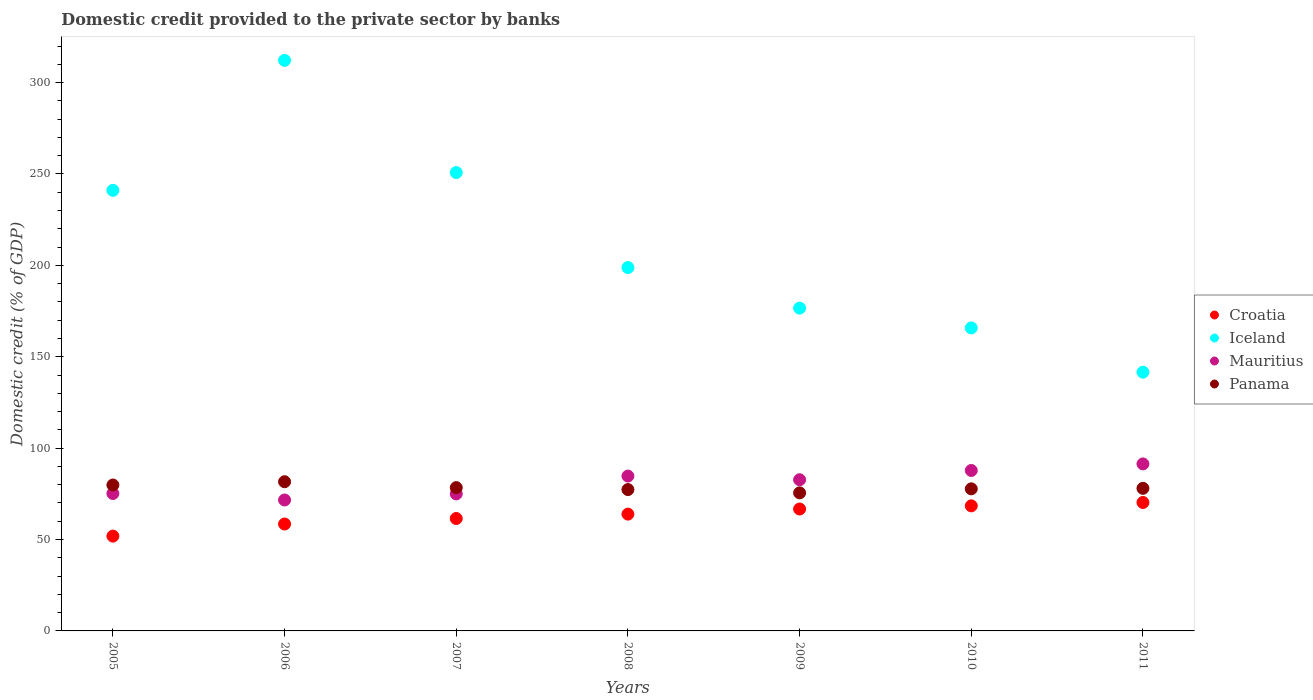How many different coloured dotlines are there?
Make the answer very short. 4. Is the number of dotlines equal to the number of legend labels?
Offer a terse response. Yes. What is the domestic credit provided to the private sector by banks in Mauritius in 2008?
Ensure brevity in your answer.  84.72. Across all years, what is the maximum domestic credit provided to the private sector by banks in Panama?
Give a very brief answer. 81.63. Across all years, what is the minimum domestic credit provided to the private sector by banks in Panama?
Provide a succinct answer. 75.54. In which year was the domestic credit provided to the private sector by banks in Mauritius maximum?
Provide a succinct answer. 2011. In which year was the domestic credit provided to the private sector by banks in Panama minimum?
Your answer should be very brief. 2009. What is the total domestic credit provided to the private sector by banks in Iceland in the graph?
Your response must be concise. 1486.71. What is the difference between the domestic credit provided to the private sector by banks in Panama in 2006 and that in 2010?
Offer a terse response. 3.89. What is the difference between the domestic credit provided to the private sector by banks in Mauritius in 2006 and the domestic credit provided to the private sector by banks in Panama in 2007?
Provide a short and direct response. -6.77. What is the average domestic credit provided to the private sector by banks in Panama per year?
Provide a short and direct response. 78.35. In the year 2011, what is the difference between the domestic credit provided to the private sector by banks in Mauritius and domestic credit provided to the private sector by banks in Croatia?
Make the answer very short. 21.1. In how many years, is the domestic credit provided to the private sector by banks in Croatia greater than 160 %?
Keep it short and to the point. 0. What is the ratio of the domestic credit provided to the private sector by banks in Mauritius in 2007 to that in 2009?
Keep it short and to the point. 0.91. Is the difference between the domestic credit provided to the private sector by banks in Mauritius in 2008 and 2011 greater than the difference between the domestic credit provided to the private sector by banks in Croatia in 2008 and 2011?
Offer a very short reply. No. What is the difference between the highest and the second highest domestic credit provided to the private sector by banks in Croatia?
Your response must be concise. 1.84. What is the difference between the highest and the lowest domestic credit provided to the private sector by banks in Iceland?
Provide a succinct answer. 170.59. In how many years, is the domestic credit provided to the private sector by banks in Panama greater than the average domestic credit provided to the private sector by banks in Panama taken over all years?
Provide a succinct answer. 3. Is it the case that in every year, the sum of the domestic credit provided to the private sector by banks in Panama and domestic credit provided to the private sector by banks in Mauritius  is greater than the sum of domestic credit provided to the private sector by banks in Iceland and domestic credit provided to the private sector by banks in Croatia?
Your answer should be very brief. Yes. Does the domestic credit provided to the private sector by banks in Croatia monotonically increase over the years?
Provide a succinct answer. Yes. Is the domestic credit provided to the private sector by banks in Mauritius strictly greater than the domestic credit provided to the private sector by banks in Panama over the years?
Provide a short and direct response. No. How many dotlines are there?
Offer a very short reply. 4. Are the values on the major ticks of Y-axis written in scientific E-notation?
Give a very brief answer. No. Does the graph contain any zero values?
Your answer should be very brief. No. Where does the legend appear in the graph?
Make the answer very short. Center right. What is the title of the graph?
Provide a short and direct response. Domestic credit provided to the private sector by banks. Does "Guinea" appear as one of the legend labels in the graph?
Keep it short and to the point. No. What is the label or title of the X-axis?
Your response must be concise. Years. What is the label or title of the Y-axis?
Provide a succinct answer. Domestic credit (% of GDP). What is the Domestic credit (% of GDP) in Croatia in 2005?
Give a very brief answer. 51.87. What is the Domestic credit (% of GDP) of Iceland in 2005?
Offer a terse response. 241.04. What is the Domestic credit (% of GDP) of Mauritius in 2005?
Ensure brevity in your answer.  75.18. What is the Domestic credit (% of GDP) in Panama in 2005?
Ensure brevity in your answer.  79.83. What is the Domestic credit (% of GDP) of Croatia in 2006?
Provide a short and direct response. 58.49. What is the Domestic credit (% of GDP) in Iceland in 2006?
Give a very brief answer. 312.15. What is the Domestic credit (% of GDP) of Mauritius in 2006?
Your answer should be compact. 71.63. What is the Domestic credit (% of GDP) of Panama in 2006?
Offer a terse response. 81.63. What is the Domestic credit (% of GDP) of Croatia in 2007?
Give a very brief answer. 61.5. What is the Domestic credit (% of GDP) in Iceland in 2007?
Provide a short and direct response. 250.76. What is the Domestic credit (% of GDP) in Mauritius in 2007?
Ensure brevity in your answer.  74.97. What is the Domestic credit (% of GDP) in Panama in 2007?
Ensure brevity in your answer.  78.4. What is the Domestic credit (% of GDP) of Croatia in 2008?
Your answer should be compact. 63.9. What is the Domestic credit (% of GDP) of Iceland in 2008?
Provide a short and direct response. 198.81. What is the Domestic credit (% of GDP) of Mauritius in 2008?
Your answer should be compact. 84.72. What is the Domestic credit (% of GDP) of Panama in 2008?
Offer a terse response. 77.33. What is the Domestic credit (% of GDP) in Croatia in 2009?
Make the answer very short. 66.7. What is the Domestic credit (% of GDP) in Iceland in 2009?
Provide a succinct answer. 176.6. What is the Domestic credit (% of GDP) of Mauritius in 2009?
Make the answer very short. 82.71. What is the Domestic credit (% of GDP) of Panama in 2009?
Provide a succinct answer. 75.54. What is the Domestic credit (% of GDP) in Croatia in 2010?
Provide a succinct answer. 68.43. What is the Domestic credit (% of GDP) of Iceland in 2010?
Keep it short and to the point. 165.78. What is the Domestic credit (% of GDP) of Mauritius in 2010?
Your response must be concise. 87.78. What is the Domestic credit (% of GDP) of Panama in 2010?
Your answer should be compact. 77.74. What is the Domestic credit (% of GDP) of Croatia in 2011?
Your answer should be compact. 70.27. What is the Domestic credit (% of GDP) in Iceland in 2011?
Provide a succinct answer. 141.56. What is the Domestic credit (% of GDP) in Mauritius in 2011?
Give a very brief answer. 91.37. What is the Domestic credit (% of GDP) in Panama in 2011?
Provide a short and direct response. 78.01. Across all years, what is the maximum Domestic credit (% of GDP) in Croatia?
Offer a terse response. 70.27. Across all years, what is the maximum Domestic credit (% of GDP) in Iceland?
Ensure brevity in your answer.  312.15. Across all years, what is the maximum Domestic credit (% of GDP) in Mauritius?
Provide a short and direct response. 91.37. Across all years, what is the maximum Domestic credit (% of GDP) in Panama?
Your answer should be very brief. 81.63. Across all years, what is the minimum Domestic credit (% of GDP) of Croatia?
Give a very brief answer. 51.87. Across all years, what is the minimum Domestic credit (% of GDP) in Iceland?
Provide a succinct answer. 141.56. Across all years, what is the minimum Domestic credit (% of GDP) in Mauritius?
Give a very brief answer. 71.63. Across all years, what is the minimum Domestic credit (% of GDP) in Panama?
Offer a terse response. 75.54. What is the total Domestic credit (% of GDP) of Croatia in the graph?
Provide a succinct answer. 441.15. What is the total Domestic credit (% of GDP) of Iceland in the graph?
Your response must be concise. 1486.71. What is the total Domestic credit (% of GDP) in Mauritius in the graph?
Provide a short and direct response. 568.36. What is the total Domestic credit (% of GDP) in Panama in the graph?
Provide a succinct answer. 548.47. What is the difference between the Domestic credit (% of GDP) in Croatia in 2005 and that in 2006?
Your response must be concise. -6.62. What is the difference between the Domestic credit (% of GDP) of Iceland in 2005 and that in 2006?
Offer a terse response. -71.11. What is the difference between the Domestic credit (% of GDP) of Mauritius in 2005 and that in 2006?
Your response must be concise. 3.55. What is the difference between the Domestic credit (% of GDP) in Panama in 2005 and that in 2006?
Keep it short and to the point. -1.8. What is the difference between the Domestic credit (% of GDP) in Croatia in 2005 and that in 2007?
Keep it short and to the point. -9.63. What is the difference between the Domestic credit (% of GDP) in Iceland in 2005 and that in 2007?
Offer a very short reply. -9.72. What is the difference between the Domestic credit (% of GDP) of Mauritius in 2005 and that in 2007?
Ensure brevity in your answer.  0.21. What is the difference between the Domestic credit (% of GDP) in Panama in 2005 and that in 2007?
Give a very brief answer. 1.43. What is the difference between the Domestic credit (% of GDP) of Croatia in 2005 and that in 2008?
Provide a succinct answer. -12.03. What is the difference between the Domestic credit (% of GDP) of Iceland in 2005 and that in 2008?
Your response must be concise. 42.24. What is the difference between the Domestic credit (% of GDP) in Mauritius in 2005 and that in 2008?
Your response must be concise. -9.55. What is the difference between the Domestic credit (% of GDP) in Panama in 2005 and that in 2008?
Keep it short and to the point. 2.5. What is the difference between the Domestic credit (% of GDP) of Croatia in 2005 and that in 2009?
Give a very brief answer. -14.83. What is the difference between the Domestic credit (% of GDP) in Iceland in 2005 and that in 2009?
Offer a terse response. 64.44. What is the difference between the Domestic credit (% of GDP) in Mauritius in 2005 and that in 2009?
Give a very brief answer. -7.53. What is the difference between the Domestic credit (% of GDP) of Panama in 2005 and that in 2009?
Make the answer very short. 4.29. What is the difference between the Domestic credit (% of GDP) in Croatia in 2005 and that in 2010?
Keep it short and to the point. -16.56. What is the difference between the Domestic credit (% of GDP) in Iceland in 2005 and that in 2010?
Your response must be concise. 75.26. What is the difference between the Domestic credit (% of GDP) in Mauritius in 2005 and that in 2010?
Ensure brevity in your answer.  -12.6. What is the difference between the Domestic credit (% of GDP) in Panama in 2005 and that in 2010?
Provide a succinct answer. 2.1. What is the difference between the Domestic credit (% of GDP) of Croatia in 2005 and that in 2011?
Give a very brief answer. -18.4. What is the difference between the Domestic credit (% of GDP) of Iceland in 2005 and that in 2011?
Offer a terse response. 99.48. What is the difference between the Domestic credit (% of GDP) of Mauritius in 2005 and that in 2011?
Provide a succinct answer. -16.19. What is the difference between the Domestic credit (% of GDP) of Panama in 2005 and that in 2011?
Ensure brevity in your answer.  1.82. What is the difference between the Domestic credit (% of GDP) of Croatia in 2006 and that in 2007?
Offer a terse response. -3.01. What is the difference between the Domestic credit (% of GDP) in Iceland in 2006 and that in 2007?
Your answer should be compact. 61.39. What is the difference between the Domestic credit (% of GDP) of Mauritius in 2006 and that in 2007?
Your response must be concise. -3.34. What is the difference between the Domestic credit (% of GDP) in Panama in 2006 and that in 2007?
Your response must be concise. 3.23. What is the difference between the Domestic credit (% of GDP) of Croatia in 2006 and that in 2008?
Your answer should be very brief. -5.41. What is the difference between the Domestic credit (% of GDP) of Iceland in 2006 and that in 2008?
Give a very brief answer. 113.35. What is the difference between the Domestic credit (% of GDP) in Mauritius in 2006 and that in 2008?
Make the answer very short. -13.09. What is the difference between the Domestic credit (% of GDP) in Panama in 2006 and that in 2008?
Offer a terse response. 4.3. What is the difference between the Domestic credit (% of GDP) in Croatia in 2006 and that in 2009?
Your answer should be compact. -8.22. What is the difference between the Domestic credit (% of GDP) in Iceland in 2006 and that in 2009?
Provide a succinct answer. 135.55. What is the difference between the Domestic credit (% of GDP) of Mauritius in 2006 and that in 2009?
Make the answer very short. -11.08. What is the difference between the Domestic credit (% of GDP) in Panama in 2006 and that in 2009?
Offer a very short reply. 6.09. What is the difference between the Domestic credit (% of GDP) of Croatia in 2006 and that in 2010?
Keep it short and to the point. -9.94. What is the difference between the Domestic credit (% of GDP) of Iceland in 2006 and that in 2010?
Give a very brief answer. 146.37. What is the difference between the Domestic credit (% of GDP) of Mauritius in 2006 and that in 2010?
Your answer should be compact. -16.15. What is the difference between the Domestic credit (% of GDP) in Panama in 2006 and that in 2010?
Offer a very short reply. 3.89. What is the difference between the Domestic credit (% of GDP) in Croatia in 2006 and that in 2011?
Your answer should be very brief. -11.78. What is the difference between the Domestic credit (% of GDP) in Iceland in 2006 and that in 2011?
Provide a succinct answer. 170.59. What is the difference between the Domestic credit (% of GDP) in Mauritius in 2006 and that in 2011?
Ensure brevity in your answer.  -19.74. What is the difference between the Domestic credit (% of GDP) of Panama in 2006 and that in 2011?
Ensure brevity in your answer.  3.62. What is the difference between the Domestic credit (% of GDP) of Croatia in 2007 and that in 2008?
Offer a very short reply. -2.4. What is the difference between the Domestic credit (% of GDP) of Iceland in 2007 and that in 2008?
Ensure brevity in your answer.  51.96. What is the difference between the Domestic credit (% of GDP) of Mauritius in 2007 and that in 2008?
Your answer should be very brief. -9.76. What is the difference between the Domestic credit (% of GDP) of Panama in 2007 and that in 2008?
Offer a terse response. 1.07. What is the difference between the Domestic credit (% of GDP) of Croatia in 2007 and that in 2009?
Give a very brief answer. -5.2. What is the difference between the Domestic credit (% of GDP) of Iceland in 2007 and that in 2009?
Make the answer very short. 74.16. What is the difference between the Domestic credit (% of GDP) of Mauritius in 2007 and that in 2009?
Offer a terse response. -7.74. What is the difference between the Domestic credit (% of GDP) of Panama in 2007 and that in 2009?
Ensure brevity in your answer.  2.86. What is the difference between the Domestic credit (% of GDP) of Croatia in 2007 and that in 2010?
Keep it short and to the point. -6.93. What is the difference between the Domestic credit (% of GDP) of Iceland in 2007 and that in 2010?
Ensure brevity in your answer.  84.98. What is the difference between the Domestic credit (% of GDP) of Mauritius in 2007 and that in 2010?
Provide a short and direct response. -12.81. What is the difference between the Domestic credit (% of GDP) of Panama in 2007 and that in 2010?
Ensure brevity in your answer.  0.66. What is the difference between the Domestic credit (% of GDP) in Croatia in 2007 and that in 2011?
Offer a terse response. -8.77. What is the difference between the Domestic credit (% of GDP) of Iceland in 2007 and that in 2011?
Give a very brief answer. 109.2. What is the difference between the Domestic credit (% of GDP) in Mauritius in 2007 and that in 2011?
Ensure brevity in your answer.  -16.4. What is the difference between the Domestic credit (% of GDP) of Panama in 2007 and that in 2011?
Provide a succinct answer. 0.39. What is the difference between the Domestic credit (% of GDP) of Croatia in 2008 and that in 2009?
Ensure brevity in your answer.  -2.8. What is the difference between the Domestic credit (% of GDP) in Iceland in 2008 and that in 2009?
Offer a very short reply. 22.2. What is the difference between the Domestic credit (% of GDP) of Mauritius in 2008 and that in 2009?
Offer a terse response. 2.01. What is the difference between the Domestic credit (% of GDP) in Panama in 2008 and that in 2009?
Provide a short and direct response. 1.79. What is the difference between the Domestic credit (% of GDP) in Croatia in 2008 and that in 2010?
Your answer should be compact. -4.53. What is the difference between the Domestic credit (% of GDP) of Iceland in 2008 and that in 2010?
Offer a terse response. 33.02. What is the difference between the Domestic credit (% of GDP) of Mauritius in 2008 and that in 2010?
Ensure brevity in your answer.  -3.06. What is the difference between the Domestic credit (% of GDP) of Panama in 2008 and that in 2010?
Provide a short and direct response. -0.41. What is the difference between the Domestic credit (% of GDP) of Croatia in 2008 and that in 2011?
Offer a terse response. -6.37. What is the difference between the Domestic credit (% of GDP) of Iceland in 2008 and that in 2011?
Give a very brief answer. 57.25. What is the difference between the Domestic credit (% of GDP) of Mauritius in 2008 and that in 2011?
Provide a short and direct response. -6.64. What is the difference between the Domestic credit (% of GDP) of Panama in 2008 and that in 2011?
Your answer should be very brief. -0.68. What is the difference between the Domestic credit (% of GDP) in Croatia in 2009 and that in 2010?
Make the answer very short. -1.73. What is the difference between the Domestic credit (% of GDP) in Iceland in 2009 and that in 2010?
Make the answer very short. 10.82. What is the difference between the Domestic credit (% of GDP) in Mauritius in 2009 and that in 2010?
Make the answer very short. -5.07. What is the difference between the Domestic credit (% of GDP) in Panama in 2009 and that in 2010?
Provide a succinct answer. -2.2. What is the difference between the Domestic credit (% of GDP) in Croatia in 2009 and that in 2011?
Offer a very short reply. -3.56. What is the difference between the Domestic credit (% of GDP) in Iceland in 2009 and that in 2011?
Ensure brevity in your answer.  35.04. What is the difference between the Domestic credit (% of GDP) of Mauritius in 2009 and that in 2011?
Offer a very short reply. -8.66. What is the difference between the Domestic credit (% of GDP) in Panama in 2009 and that in 2011?
Provide a short and direct response. -2.47. What is the difference between the Domestic credit (% of GDP) in Croatia in 2010 and that in 2011?
Give a very brief answer. -1.84. What is the difference between the Domestic credit (% of GDP) in Iceland in 2010 and that in 2011?
Ensure brevity in your answer.  24.22. What is the difference between the Domestic credit (% of GDP) of Mauritius in 2010 and that in 2011?
Offer a terse response. -3.59. What is the difference between the Domestic credit (% of GDP) of Panama in 2010 and that in 2011?
Offer a very short reply. -0.27. What is the difference between the Domestic credit (% of GDP) in Croatia in 2005 and the Domestic credit (% of GDP) in Iceland in 2006?
Your answer should be compact. -260.28. What is the difference between the Domestic credit (% of GDP) in Croatia in 2005 and the Domestic credit (% of GDP) in Mauritius in 2006?
Offer a very short reply. -19.76. What is the difference between the Domestic credit (% of GDP) in Croatia in 2005 and the Domestic credit (% of GDP) in Panama in 2006?
Provide a succinct answer. -29.76. What is the difference between the Domestic credit (% of GDP) of Iceland in 2005 and the Domestic credit (% of GDP) of Mauritius in 2006?
Offer a terse response. 169.41. What is the difference between the Domestic credit (% of GDP) in Iceland in 2005 and the Domestic credit (% of GDP) in Panama in 2006?
Your answer should be compact. 159.42. What is the difference between the Domestic credit (% of GDP) in Mauritius in 2005 and the Domestic credit (% of GDP) in Panama in 2006?
Your answer should be compact. -6.45. What is the difference between the Domestic credit (% of GDP) in Croatia in 2005 and the Domestic credit (% of GDP) in Iceland in 2007?
Your answer should be very brief. -198.89. What is the difference between the Domestic credit (% of GDP) of Croatia in 2005 and the Domestic credit (% of GDP) of Mauritius in 2007?
Your response must be concise. -23.1. What is the difference between the Domestic credit (% of GDP) of Croatia in 2005 and the Domestic credit (% of GDP) of Panama in 2007?
Offer a terse response. -26.53. What is the difference between the Domestic credit (% of GDP) in Iceland in 2005 and the Domestic credit (% of GDP) in Mauritius in 2007?
Your answer should be very brief. 166.08. What is the difference between the Domestic credit (% of GDP) of Iceland in 2005 and the Domestic credit (% of GDP) of Panama in 2007?
Give a very brief answer. 162.64. What is the difference between the Domestic credit (% of GDP) in Mauritius in 2005 and the Domestic credit (% of GDP) in Panama in 2007?
Offer a very short reply. -3.22. What is the difference between the Domestic credit (% of GDP) of Croatia in 2005 and the Domestic credit (% of GDP) of Iceland in 2008?
Your response must be concise. -146.94. What is the difference between the Domestic credit (% of GDP) in Croatia in 2005 and the Domestic credit (% of GDP) in Mauritius in 2008?
Make the answer very short. -32.85. What is the difference between the Domestic credit (% of GDP) of Croatia in 2005 and the Domestic credit (% of GDP) of Panama in 2008?
Keep it short and to the point. -25.46. What is the difference between the Domestic credit (% of GDP) of Iceland in 2005 and the Domestic credit (% of GDP) of Mauritius in 2008?
Your response must be concise. 156.32. What is the difference between the Domestic credit (% of GDP) of Iceland in 2005 and the Domestic credit (% of GDP) of Panama in 2008?
Your response must be concise. 163.72. What is the difference between the Domestic credit (% of GDP) of Mauritius in 2005 and the Domestic credit (% of GDP) of Panama in 2008?
Your answer should be very brief. -2.15. What is the difference between the Domestic credit (% of GDP) in Croatia in 2005 and the Domestic credit (% of GDP) in Iceland in 2009?
Your response must be concise. -124.73. What is the difference between the Domestic credit (% of GDP) in Croatia in 2005 and the Domestic credit (% of GDP) in Mauritius in 2009?
Keep it short and to the point. -30.84. What is the difference between the Domestic credit (% of GDP) in Croatia in 2005 and the Domestic credit (% of GDP) in Panama in 2009?
Ensure brevity in your answer.  -23.67. What is the difference between the Domestic credit (% of GDP) in Iceland in 2005 and the Domestic credit (% of GDP) in Mauritius in 2009?
Offer a terse response. 158.33. What is the difference between the Domestic credit (% of GDP) of Iceland in 2005 and the Domestic credit (% of GDP) of Panama in 2009?
Provide a short and direct response. 165.51. What is the difference between the Domestic credit (% of GDP) in Mauritius in 2005 and the Domestic credit (% of GDP) in Panama in 2009?
Ensure brevity in your answer.  -0.36. What is the difference between the Domestic credit (% of GDP) in Croatia in 2005 and the Domestic credit (% of GDP) in Iceland in 2010?
Your response must be concise. -113.91. What is the difference between the Domestic credit (% of GDP) of Croatia in 2005 and the Domestic credit (% of GDP) of Mauritius in 2010?
Make the answer very short. -35.91. What is the difference between the Domestic credit (% of GDP) of Croatia in 2005 and the Domestic credit (% of GDP) of Panama in 2010?
Your response must be concise. -25.87. What is the difference between the Domestic credit (% of GDP) of Iceland in 2005 and the Domestic credit (% of GDP) of Mauritius in 2010?
Your answer should be very brief. 153.26. What is the difference between the Domestic credit (% of GDP) of Iceland in 2005 and the Domestic credit (% of GDP) of Panama in 2010?
Keep it short and to the point. 163.31. What is the difference between the Domestic credit (% of GDP) in Mauritius in 2005 and the Domestic credit (% of GDP) in Panama in 2010?
Provide a short and direct response. -2.56. What is the difference between the Domestic credit (% of GDP) in Croatia in 2005 and the Domestic credit (% of GDP) in Iceland in 2011?
Keep it short and to the point. -89.69. What is the difference between the Domestic credit (% of GDP) of Croatia in 2005 and the Domestic credit (% of GDP) of Mauritius in 2011?
Give a very brief answer. -39.5. What is the difference between the Domestic credit (% of GDP) of Croatia in 2005 and the Domestic credit (% of GDP) of Panama in 2011?
Your answer should be very brief. -26.14. What is the difference between the Domestic credit (% of GDP) in Iceland in 2005 and the Domestic credit (% of GDP) in Mauritius in 2011?
Your response must be concise. 149.68. What is the difference between the Domestic credit (% of GDP) of Iceland in 2005 and the Domestic credit (% of GDP) of Panama in 2011?
Make the answer very short. 163.04. What is the difference between the Domestic credit (% of GDP) in Mauritius in 2005 and the Domestic credit (% of GDP) in Panama in 2011?
Keep it short and to the point. -2.83. What is the difference between the Domestic credit (% of GDP) of Croatia in 2006 and the Domestic credit (% of GDP) of Iceland in 2007?
Make the answer very short. -192.28. What is the difference between the Domestic credit (% of GDP) in Croatia in 2006 and the Domestic credit (% of GDP) in Mauritius in 2007?
Provide a succinct answer. -16.48. What is the difference between the Domestic credit (% of GDP) of Croatia in 2006 and the Domestic credit (% of GDP) of Panama in 2007?
Your answer should be very brief. -19.91. What is the difference between the Domestic credit (% of GDP) in Iceland in 2006 and the Domestic credit (% of GDP) in Mauritius in 2007?
Offer a terse response. 237.19. What is the difference between the Domestic credit (% of GDP) of Iceland in 2006 and the Domestic credit (% of GDP) of Panama in 2007?
Offer a very short reply. 233.75. What is the difference between the Domestic credit (% of GDP) in Mauritius in 2006 and the Domestic credit (% of GDP) in Panama in 2007?
Provide a succinct answer. -6.77. What is the difference between the Domestic credit (% of GDP) of Croatia in 2006 and the Domestic credit (% of GDP) of Iceland in 2008?
Provide a short and direct response. -140.32. What is the difference between the Domestic credit (% of GDP) of Croatia in 2006 and the Domestic credit (% of GDP) of Mauritius in 2008?
Your answer should be very brief. -26.24. What is the difference between the Domestic credit (% of GDP) of Croatia in 2006 and the Domestic credit (% of GDP) of Panama in 2008?
Ensure brevity in your answer.  -18.84. What is the difference between the Domestic credit (% of GDP) in Iceland in 2006 and the Domestic credit (% of GDP) in Mauritius in 2008?
Ensure brevity in your answer.  227.43. What is the difference between the Domestic credit (% of GDP) in Iceland in 2006 and the Domestic credit (% of GDP) in Panama in 2008?
Provide a short and direct response. 234.82. What is the difference between the Domestic credit (% of GDP) of Mauritius in 2006 and the Domestic credit (% of GDP) of Panama in 2008?
Offer a very short reply. -5.7. What is the difference between the Domestic credit (% of GDP) of Croatia in 2006 and the Domestic credit (% of GDP) of Iceland in 2009?
Your answer should be compact. -118.12. What is the difference between the Domestic credit (% of GDP) in Croatia in 2006 and the Domestic credit (% of GDP) in Mauritius in 2009?
Your answer should be compact. -24.23. What is the difference between the Domestic credit (% of GDP) in Croatia in 2006 and the Domestic credit (% of GDP) in Panama in 2009?
Make the answer very short. -17.05. What is the difference between the Domestic credit (% of GDP) of Iceland in 2006 and the Domestic credit (% of GDP) of Mauritius in 2009?
Provide a succinct answer. 229.44. What is the difference between the Domestic credit (% of GDP) of Iceland in 2006 and the Domestic credit (% of GDP) of Panama in 2009?
Offer a very short reply. 236.62. What is the difference between the Domestic credit (% of GDP) of Mauritius in 2006 and the Domestic credit (% of GDP) of Panama in 2009?
Ensure brevity in your answer.  -3.91. What is the difference between the Domestic credit (% of GDP) in Croatia in 2006 and the Domestic credit (% of GDP) in Iceland in 2010?
Offer a terse response. -107.3. What is the difference between the Domestic credit (% of GDP) in Croatia in 2006 and the Domestic credit (% of GDP) in Mauritius in 2010?
Offer a terse response. -29.3. What is the difference between the Domestic credit (% of GDP) of Croatia in 2006 and the Domestic credit (% of GDP) of Panama in 2010?
Your answer should be compact. -19.25. What is the difference between the Domestic credit (% of GDP) of Iceland in 2006 and the Domestic credit (% of GDP) of Mauritius in 2010?
Your answer should be compact. 224.37. What is the difference between the Domestic credit (% of GDP) in Iceland in 2006 and the Domestic credit (% of GDP) in Panama in 2010?
Keep it short and to the point. 234.42. What is the difference between the Domestic credit (% of GDP) of Mauritius in 2006 and the Domestic credit (% of GDP) of Panama in 2010?
Offer a terse response. -6.1. What is the difference between the Domestic credit (% of GDP) of Croatia in 2006 and the Domestic credit (% of GDP) of Iceland in 2011?
Your answer should be very brief. -83.07. What is the difference between the Domestic credit (% of GDP) in Croatia in 2006 and the Domestic credit (% of GDP) in Mauritius in 2011?
Make the answer very short. -32.88. What is the difference between the Domestic credit (% of GDP) of Croatia in 2006 and the Domestic credit (% of GDP) of Panama in 2011?
Provide a succinct answer. -19.52. What is the difference between the Domestic credit (% of GDP) in Iceland in 2006 and the Domestic credit (% of GDP) in Mauritius in 2011?
Your answer should be compact. 220.79. What is the difference between the Domestic credit (% of GDP) in Iceland in 2006 and the Domestic credit (% of GDP) in Panama in 2011?
Offer a terse response. 234.15. What is the difference between the Domestic credit (% of GDP) of Mauritius in 2006 and the Domestic credit (% of GDP) of Panama in 2011?
Offer a terse response. -6.38. What is the difference between the Domestic credit (% of GDP) in Croatia in 2007 and the Domestic credit (% of GDP) in Iceland in 2008?
Ensure brevity in your answer.  -137.31. What is the difference between the Domestic credit (% of GDP) in Croatia in 2007 and the Domestic credit (% of GDP) in Mauritius in 2008?
Give a very brief answer. -23.22. What is the difference between the Domestic credit (% of GDP) of Croatia in 2007 and the Domestic credit (% of GDP) of Panama in 2008?
Keep it short and to the point. -15.83. What is the difference between the Domestic credit (% of GDP) in Iceland in 2007 and the Domestic credit (% of GDP) in Mauritius in 2008?
Provide a succinct answer. 166.04. What is the difference between the Domestic credit (% of GDP) in Iceland in 2007 and the Domestic credit (% of GDP) in Panama in 2008?
Make the answer very short. 173.43. What is the difference between the Domestic credit (% of GDP) of Mauritius in 2007 and the Domestic credit (% of GDP) of Panama in 2008?
Your answer should be very brief. -2.36. What is the difference between the Domestic credit (% of GDP) of Croatia in 2007 and the Domestic credit (% of GDP) of Iceland in 2009?
Your response must be concise. -115.1. What is the difference between the Domestic credit (% of GDP) in Croatia in 2007 and the Domestic credit (% of GDP) in Mauritius in 2009?
Make the answer very short. -21.21. What is the difference between the Domestic credit (% of GDP) of Croatia in 2007 and the Domestic credit (% of GDP) of Panama in 2009?
Your answer should be compact. -14.04. What is the difference between the Domestic credit (% of GDP) of Iceland in 2007 and the Domestic credit (% of GDP) of Mauritius in 2009?
Offer a terse response. 168.05. What is the difference between the Domestic credit (% of GDP) of Iceland in 2007 and the Domestic credit (% of GDP) of Panama in 2009?
Your response must be concise. 175.23. What is the difference between the Domestic credit (% of GDP) in Mauritius in 2007 and the Domestic credit (% of GDP) in Panama in 2009?
Provide a short and direct response. -0.57. What is the difference between the Domestic credit (% of GDP) in Croatia in 2007 and the Domestic credit (% of GDP) in Iceland in 2010?
Keep it short and to the point. -104.28. What is the difference between the Domestic credit (% of GDP) of Croatia in 2007 and the Domestic credit (% of GDP) of Mauritius in 2010?
Keep it short and to the point. -26.28. What is the difference between the Domestic credit (% of GDP) of Croatia in 2007 and the Domestic credit (% of GDP) of Panama in 2010?
Offer a very short reply. -16.24. What is the difference between the Domestic credit (% of GDP) in Iceland in 2007 and the Domestic credit (% of GDP) in Mauritius in 2010?
Give a very brief answer. 162.98. What is the difference between the Domestic credit (% of GDP) in Iceland in 2007 and the Domestic credit (% of GDP) in Panama in 2010?
Keep it short and to the point. 173.03. What is the difference between the Domestic credit (% of GDP) in Mauritius in 2007 and the Domestic credit (% of GDP) in Panama in 2010?
Make the answer very short. -2.77. What is the difference between the Domestic credit (% of GDP) of Croatia in 2007 and the Domestic credit (% of GDP) of Iceland in 2011?
Provide a succinct answer. -80.06. What is the difference between the Domestic credit (% of GDP) in Croatia in 2007 and the Domestic credit (% of GDP) in Mauritius in 2011?
Provide a short and direct response. -29.87. What is the difference between the Domestic credit (% of GDP) in Croatia in 2007 and the Domestic credit (% of GDP) in Panama in 2011?
Offer a terse response. -16.51. What is the difference between the Domestic credit (% of GDP) in Iceland in 2007 and the Domestic credit (% of GDP) in Mauritius in 2011?
Your answer should be compact. 159.39. What is the difference between the Domestic credit (% of GDP) in Iceland in 2007 and the Domestic credit (% of GDP) in Panama in 2011?
Ensure brevity in your answer.  172.76. What is the difference between the Domestic credit (% of GDP) of Mauritius in 2007 and the Domestic credit (% of GDP) of Panama in 2011?
Your answer should be very brief. -3.04. What is the difference between the Domestic credit (% of GDP) in Croatia in 2008 and the Domestic credit (% of GDP) in Iceland in 2009?
Your answer should be compact. -112.7. What is the difference between the Domestic credit (% of GDP) in Croatia in 2008 and the Domestic credit (% of GDP) in Mauritius in 2009?
Give a very brief answer. -18.81. What is the difference between the Domestic credit (% of GDP) of Croatia in 2008 and the Domestic credit (% of GDP) of Panama in 2009?
Offer a terse response. -11.64. What is the difference between the Domestic credit (% of GDP) in Iceland in 2008 and the Domestic credit (% of GDP) in Mauritius in 2009?
Your answer should be compact. 116.09. What is the difference between the Domestic credit (% of GDP) in Iceland in 2008 and the Domestic credit (% of GDP) in Panama in 2009?
Your answer should be compact. 123.27. What is the difference between the Domestic credit (% of GDP) of Mauritius in 2008 and the Domestic credit (% of GDP) of Panama in 2009?
Provide a succinct answer. 9.19. What is the difference between the Domestic credit (% of GDP) in Croatia in 2008 and the Domestic credit (% of GDP) in Iceland in 2010?
Ensure brevity in your answer.  -101.88. What is the difference between the Domestic credit (% of GDP) of Croatia in 2008 and the Domestic credit (% of GDP) of Mauritius in 2010?
Your answer should be compact. -23.88. What is the difference between the Domestic credit (% of GDP) in Croatia in 2008 and the Domestic credit (% of GDP) in Panama in 2010?
Make the answer very short. -13.84. What is the difference between the Domestic credit (% of GDP) of Iceland in 2008 and the Domestic credit (% of GDP) of Mauritius in 2010?
Provide a succinct answer. 111.02. What is the difference between the Domestic credit (% of GDP) of Iceland in 2008 and the Domestic credit (% of GDP) of Panama in 2010?
Your answer should be compact. 121.07. What is the difference between the Domestic credit (% of GDP) of Mauritius in 2008 and the Domestic credit (% of GDP) of Panama in 2010?
Give a very brief answer. 6.99. What is the difference between the Domestic credit (% of GDP) of Croatia in 2008 and the Domestic credit (% of GDP) of Iceland in 2011?
Offer a very short reply. -77.66. What is the difference between the Domestic credit (% of GDP) of Croatia in 2008 and the Domestic credit (% of GDP) of Mauritius in 2011?
Your answer should be compact. -27.47. What is the difference between the Domestic credit (% of GDP) in Croatia in 2008 and the Domestic credit (% of GDP) in Panama in 2011?
Ensure brevity in your answer.  -14.11. What is the difference between the Domestic credit (% of GDP) in Iceland in 2008 and the Domestic credit (% of GDP) in Mauritius in 2011?
Provide a short and direct response. 107.44. What is the difference between the Domestic credit (% of GDP) of Iceland in 2008 and the Domestic credit (% of GDP) of Panama in 2011?
Your response must be concise. 120.8. What is the difference between the Domestic credit (% of GDP) of Mauritius in 2008 and the Domestic credit (% of GDP) of Panama in 2011?
Provide a short and direct response. 6.72. What is the difference between the Domestic credit (% of GDP) in Croatia in 2009 and the Domestic credit (% of GDP) in Iceland in 2010?
Provide a succinct answer. -99.08. What is the difference between the Domestic credit (% of GDP) of Croatia in 2009 and the Domestic credit (% of GDP) of Mauritius in 2010?
Keep it short and to the point. -21.08. What is the difference between the Domestic credit (% of GDP) in Croatia in 2009 and the Domestic credit (% of GDP) in Panama in 2010?
Your answer should be very brief. -11.03. What is the difference between the Domestic credit (% of GDP) of Iceland in 2009 and the Domestic credit (% of GDP) of Mauritius in 2010?
Provide a short and direct response. 88.82. What is the difference between the Domestic credit (% of GDP) of Iceland in 2009 and the Domestic credit (% of GDP) of Panama in 2010?
Your response must be concise. 98.87. What is the difference between the Domestic credit (% of GDP) of Mauritius in 2009 and the Domestic credit (% of GDP) of Panama in 2010?
Your answer should be compact. 4.98. What is the difference between the Domestic credit (% of GDP) of Croatia in 2009 and the Domestic credit (% of GDP) of Iceland in 2011?
Keep it short and to the point. -74.86. What is the difference between the Domestic credit (% of GDP) in Croatia in 2009 and the Domestic credit (% of GDP) in Mauritius in 2011?
Make the answer very short. -24.66. What is the difference between the Domestic credit (% of GDP) in Croatia in 2009 and the Domestic credit (% of GDP) in Panama in 2011?
Your answer should be compact. -11.3. What is the difference between the Domestic credit (% of GDP) in Iceland in 2009 and the Domestic credit (% of GDP) in Mauritius in 2011?
Provide a short and direct response. 85.23. What is the difference between the Domestic credit (% of GDP) in Iceland in 2009 and the Domestic credit (% of GDP) in Panama in 2011?
Offer a terse response. 98.59. What is the difference between the Domestic credit (% of GDP) in Mauritius in 2009 and the Domestic credit (% of GDP) in Panama in 2011?
Ensure brevity in your answer.  4.7. What is the difference between the Domestic credit (% of GDP) of Croatia in 2010 and the Domestic credit (% of GDP) of Iceland in 2011?
Offer a very short reply. -73.13. What is the difference between the Domestic credit (% of GDP) of Croatia in 2010 and the Domestic credit (% of GDP) of Mauritius in 2011?
Ensure brevity in your answer.  -22.94. What is the difference between the Domestic credit (% of GDP) of Croatia in 2010 and the Domestic credit (% of GDP) of Panama in 2011?
Keep it short and to the point. -9.58. What is the difference between the Domestic credit (% of GDP) in Iceland in 2010 and the Domestic credit (% of GDP) in Mauritius in 2011?
Give a very brief answer. 74.42. What is the difference between the Domestic credit (% of GDP) of Iceland in 2010 and the Domestic credit (% of GDP) of Panama in 2011?
Keep it short and to the point. 87.78. What is the difference between the Domestic credit (% of GDP) of Mauritius in 2010 and the Domestic credit (% of GDP) of Panama in 2011?
Ensure brevity in your answer.  9.78. What is the average Domestic credit (% of GDP) in Croatia per year?
Your response must be concise. 63.02. What is the average Domestic credit (% of GDP) of Iceland per year?
Offer a very short reply. 212.39. What is the average Domestic credit (% of GDP) in Mauritius per year?
Provide a succinct answer. 81.19. What is the average Domestic credit (% of GDP) of Panama per year?
Your response must be concise. 78.35. In the year 2005, what is the difference between the Domestic credit (% of GDP) of Croatia and Domestic credit (% of GDP) of Iceland?
Provide a succinct answer. -189.17. In the year 2005, what is the difference between the Domestic credit (% of GDP) in Croatia and Domestic credit (% of GDP) in Mauritius?
Your answer should be very brief. -23.31. In the year 2005, what is the difference between the Domestic credit (% of GDP) of Croatia and Domestic credit (% of GDP) of Panama?
Offer a very short reply. -27.96. In the year 2005, what is the difference between the Domestic credit (% of GDP) in Iceland and Domestic credit (% of GDP) in Mauritius?
Offer a terse response. 165.87. In the year 2005, what is the difference between the Domestic credit (% of GDP) in Iceland and Domestic credit (% of GDP) in Panama?
Ensure brevity in your answer.  161.21. In the year 2005, what is the difference between the Domestic credit (% of GDP) in Mauritius and Domestic credit (% of GDP) in Panama?
Offer a terse response. -4.65. In the year 2006, what is the difference between the Domestic credit (% of GDP) of Croatia and Domestic credit (% of GDP) of Iceland?
Offer a very short reply. -253.67. In the year 2006, what is the difference between the Domestic credit (% of GDP) in Croatia and Domestic credit (% of GDP) in Mauritius?
Provide a short and direct response. -13.15. In the year 2006, what is the difference between the Domestic credit (% of GDP) of Croatia and Domestic credit (% of GDP) of Panama?
Your response must be concise. -23.14. In the year 2006, what is the difference between the Domestic credit (% of GDP) in Iceland and Domestic credit (% of GDP) in Mauritius?
Provide a short and direct response. 240.52. In the year 2006, what is the difference between the Domestic credit (% of GDP) of Iceland and Domestic credit (% of GDP) of Panama?
Offer a terse response. 230.53. In the year 2006, what is the difference between the Domestic credit (% of GDP) in Mauritius and Domestic credit (% of GDP) in Panama?
Offer a very short reply. -10. In the year 2007, what is the difference between the Domestic credit (% of GDP) of Croatia and Domestic credit (% of GDP) of Iceland?
Provide a succinct answer. -189.26. In the year 2007, what is the difference between the Domestic credit (% of GDP) in Croatia and Domestic credit (% of GDP) in Mauritius?
Make the answer very short. -13.47. In the year 2007, what is the difference between the Domestic credit (% of GDP) in Croatia and Domestic credit (% of GDP) in Panama?
Your response must be concise. -16.9. In the year 2007, what is the difference between the Domestic credit (% of GDP) of Iceland and Domestic credit (% of GDP) of Mauritius?
Keep it short and to the point. 175.79. In the year 2007, what is the difference between the Domestic credit (% of GDP) in Iceland and Domestic credit (% of GDP) in Panama?
Provide a succinct answer. 172.36. In the year 2007, what is the difference between the Domestic credit (% of GDP) of Mauritius and Domestic credit (% of GDP) of Panama?
Provide a short and direct response. -3.43. In the year 2008, what is the difference between the Domestic credit (% of GDP) in Croatia and Domestic credit (% of GDP) in Iceland?
Your answer should be very brief. -134.91. In the year 2008, what is the difference between the Domestic credit (% of GDP) of Croatia and Domestic credit (% of GDP) of Mauritius?
Your answer should be very brief. -20.82. In the year 2008, what is the difference between the Domestic credit (% of GDP) in Croatia and Domestic credit (% of GDP) in Panama?
Your response must be concise. -13.43. In the year 2008, what is the difference between the Domestic credit (% of GDP) of Iceland and Domestic credit (% of GDP) of Mauritius?
Your answer should be very brief. 114.08. In the year 2008, what is the difference between the Domestic credit (% of GDP) in Iceland and Domestic credit (% of GDP) in Panama?
Ensure brevity in your answer.  121.48. In the year 2008, what is the difference between the Domestic credit (% of GDP) in Mauritius and Domestic credit (% of GDP) in Panama?
Offer a very short reply. 7.4. In the year 2009, what is the difference between the Domestic credit (% of GDP) in Croatia and Domestic credit (% of GDP) in Iceland?
Make the answer very short. -109.9. In the year 2009, what is the difference between the Domestic credit (% of GDP) of Croatia and Domestic credit (% of GDP) of Mauritius?
Ensure brevity in your answer.  -16.01. In the year 2009, what is the difference between the Domestic credit (% of GDP) in Croatia and Domestic credit (% of GDP) in Panama?
Your response must be concise. -8.83. In the year 2009, what is the difference between the Domestic credit (% of GDP) in Iceland and Domestic credit (% of GDP) in Mauritius?
Provide a short and direct response. 93.89. In the year 2009, what is the difference between the Domestic credit (% of GDP) of Iceland and Domestic credit (% of GDP) of Panama?
Your response must be concise. 101.06. In the year 2009, what is the difference between the Domestic credit (% of GDP) in Mauritius and Domestic credit (% of GDP) in Panama?
Keep it short and to the point. 7.17. In the year 2010, what is the difference between the Domestic credit (% of GDP) in Croatia and Domestic credit (% of GDP) in Iceland?
Your answer should be very brief. -97.36. In the year 2010, what is the difference between the Domestic credit (% of GDP) of Croatia and Domestic credit (% of GDP) of Mauritius?
Keep it short and to the point. -19.35. In the year 2010, what is the difference between the Domestic credit (% of GDP) in Croatia and Domestic credit (% of GDP) in Panama?
Your response must be concise. -9.31. In the year 2010, what is the difference between the Domestic credit (% of GDP) of Iceland and Domestic credit (% of GDP) of Mauritius?
Your response must be concise. 78. In the year 2010, what is the difference between the Domestic credit (% of GDP) of Iceland and Domestic credit (% of GDP) of Panama?
Your answer should be compact. 88.05. In the year 2010, what is the difference between the Domestic credit (% of GDP) of Mauritius and Domestic credit (% of GDP) of Panama?
Give a very brief answer. 10.05. In the year 2011, what is the difference between the Domestic credit (% of GDP) in Croatia and Domestic credit (% of GDP) in Iceland?
Your response must be concise. -71.29. In the year 2011, what is the difference between the Domestic credit (% of GDP) in Croatia and Domestic credit (% of GDP) in Mauritius?
Provide a succinct answer. -21.1. In the year 2011, what is the difference between the Domestic credit (% of GDP) of Croatia and Domestic credit (% of GDP) of Panama?
Offer a terse response. -7.74. In the year 2011, what is the difference between the Domestic credit (% of GDP) in Iceland and Domestic credit (% of GDP) in Mauritius?
Provide a short and direct response. 50.19. In the year 2011, what is the difference between the Domestic credit (% of GDP) in Iceland and Domestic credit (% of GDP) in Panama?
Give a very brief answer. 63.55. In the year 2011, what is the difference between the Domestic credit (% of GDP) of Mauritius and Domestic credit (% of GDP) of Panama?
Your answer should be very brief. 13.36. What is the ratio of the Domestic credit (% of GDP) in Croatia in 2005 to that in 2006?
Make the answer very short. 0.89. What is the ratio of the Domestic credit (% of GDP) of Iceland in 2005 to that in 2006?
Your response must be concise. 0.77. What is the ratio of the Domestic credit (% of GDP) in Mauritius in 2005 to that in 2006?
Keep it short and to the point. 1.05. What is the ratio of the Domestic credit (% of GDP) of Croatia in 2005 to that in 2007?
Provide a succinct answer. 0.84. What is the ratio of the Domestic credit (% of GDP) in Iceland in 2005 to that in 2007?
Your answer should be compact. 0.96. What is the ratio of the Domestic credit (% of GDP) in Mauritius in 2005 to that in 2007?
Give a very brief answer. 1. What is the ratio of the Domestic credit (% of GDP) of Panama in 2005 to that in 2007?
Make the answer very short. 1.02. What is the ratio of the Domestic credit (% of GDP) in Croatia in 2005 to that in 2008?
Keep it short and to the point. 0.81. What is the ratio of the Domestic credit (% of GDP) in Iceland in 2005 to that in 2008?
Your answer should be compact. 1.21. What is the ratio of the Domestic credit (% of GDP) of Mauritius in 2005 to that in 2008?
Provide a short and direct response. 0.89. What is the ratio of the Domestic credit (% of GDP) in Panama in 2005 to that in 2008?
Make the answer very short. 1.03. What is the ratio of the Domestic credit (% of GDP) in Croatia in 2005 to that in 2009?
Your response must be concise. 0.78. What is the ratio of the Domestic credit (% of GDP) in Iceland in 2005 to that in 2009?
Your response must be concise. 1.36. What is the ratio of the Domestic credit (% of GDP) of Mauritius in 2005 to that in 2009?
Offer a very short reply. 0.91. What is the ratio of the Domestic credit (% of GDP) in Panama in 2005 to that in 2009?
Make the answer very short. 1.06. What is the ratio of the Domestic credit (% of GDP) in Croatia in 2005 to that in 2010?
Offer a very short reply. 0.76. What is the ratio of the Domestic credit (% of GDP) of Iceland in 2005 to that in 2010?
Keep it short and to the point. 1.45. What is the ratio of the Domestic credit (% of GDP) in Mauritius in 2005 to that in 2010?
Your response must be concise. 0.86. What is the ratio of the Domestic credit (% of GDP) of Panama in 2005 to that in 2010?
Offer a terse response. 1.03. What is the ratio of the Domestic credit (% of GDP) of Croatia in 2005 to that in 2011?
Your answer should be very brief. 0.74. What is the ratio of the Domestic credit (% of GDP) in Iceland in 2005 to that in 2011?
Give a very brief answer. 1.7. What is the ratio of the Domestic credit (% of GDP) in Mauritius in 2005 to that in 2011?
Provide a succinct answer. 0.82. What is the ratio of the Domestic credit (% of GDP) in Panama in 2005 to that in 2011?
Give a very brief answer. 1.02. What is the ratio of the Domestic credit (% of GDP) in Croatia in 2006 to that in 2007?
Keep it short and to the point. 0.95. What is the ratio of the Domestic credit (% of GDP) in Iceland in 2006 to that in 2007?
Provide a short and direct response. 1.24. What is the ratio of the Domestic credit (% of GDP) of Mauritius in 2006 to that in 2007?
Your response must be concise. 0.96. What is the ratio of the Domestic credit (% of GDP) of Panama in 2006 to that in 2007?
Make the answer very short. 1.04. What is the ratio of the Domestic credit (% of GDP) in Croatia in 2006 to that in 2008?
Provide a succinct answer. 0.92. What is the ratio of the Domestic credit (% of GDP) in Iceland in 2006 to that in 2008?
Offer a terse response. 1.57. What is the ratio of the Domestic credit (% of GDP) of Mauritius in 2006 to that in 2008?
Offer a very short reply. 0.85. What is the ratio of the Domestic credit (% of GDP) of Panama in 2006 to that in 2008?
Your answer should be compact. 1.06. What is the ratio of the Domestic credit (% of GDP) in Croatia in 2006 to that in 2009?
Provide a short and direct response. 0.88. What is the ratio of the Domestic credit (% of GDP) of Iceland in 2006 to that in 2009?
Ensure brevity in your answer.  1.77. What is the ratio of the Domestic credit (% of GDP) in Mauritius in 2006 to that in 2009?
Your response must be concise. 0.87. What is the ratio of the Domestic credit (% of GDP) in Panama in 2006 to that in 2009?
Offer a very short reply. 1.08. What is the ratio of the Domestic credit (% of GDP) of Croatia in 2006 to that in 2010?
Your response must be concise. 0.85. What is the ratio of the Domestic credit (% of GDP) of Iceland in 2006 to that in 2010?
Provide a succinct answer. 1.88. What is the ratio of the Domestic credit (% of GDP) in Mauritius in 2006 to that in 2010?
Provide a succinct answer. 0.82. What is the ratio of the Domestic credit (% of GDP) of Panama in 2006 to that in 2010?
Your response must be concise. 1.05. What is the ratio of the Domestic credit (% of GDP) of Croatia in 2006 to that in 2011?
Your response must be concise. 0.83. What is the ratio of the Domestic credit (% of GDP) in Iceland in 2006 to that in 2011?
Your answer should be very brief. 2.21. What is the ratio of the Domestic credit (% of GDP) in Mauritius in 2006 to that in 2011?
Provide a short and direct response. 0.78. What is the ratio of the Domestic credit (% of GDP) of Panama in 2006 to that in 2011?
Ensure brevity in your answer.  1.05. What is the ratio of the Domestic credit (% of GDP) of Croatia in 2007 to that in 2008?
Provide a succinct answer. 0.96. What is the ratio of the Domestic credit (% of GDP) of Iceland in 2007 to that in 2008?
Offer a very short reply. 1.26. What is the ratio of the Domestic credit (% of GDP) of Mauritius in 2007 to that in 2008?
Ensure brevity in your answer.  0.88. What is the ratio of the Domestic credit (% of GDP) in Panama in 2007 to that in 2008?
Keep it short and to the point. 1.01. What is the ratio of the Domestic credit (% of GDP) of Croatia in 2007 to that in 2009?
Your answer should be very brief. 0.92. What is the ratio of the Domestic credit (% of GDP) of Iceland in 2007 to that in 2009?
Ensure brevity in your answer.  1.42. What is the ratio of the Domestic credit (% of GDP) in Mauritius in 2007 to that in 2009?
Offer a very short reply. 0.91. What is the ratio of the Domestic credit (% of GDP) of Panama in 2007 to that in 2009?
Give a very brief answer. 1.04. What is the ratio of the Domestic credit (% of GDP) of Croatia in 2007 to that in 2010?
Offer a very short reply. 0.9. What is the ratio of the Domestic credit (% of GDP) in Iceland in 2007 to that in 2010?
Provide a short and direct response. 1.51. What is the ratio of the Domestic credit (% of GDP) in Mauritius in 2007 to that in 2010?
Offer a terse response. 0.85. What is the ratio of the Domestic credit (% of GDP) in Panama in 2007 to that in 2010?
Give a very brief answer. 1.01. What is the ratio of the Domestic credit (% of GDP) of Croatia in 2007 to that in 2011?
Give a very brief answer. 0.88. What is the ratio of the Domestic credit (% of GDP) of Iceland in 2007 to that in 2011?
Provide a short and direct response. 1.77. What is the ratio of the Domestic credit (% of GDP) of Mauritius in 2007 to that in 2011?
Ensure brevity in your answer.  0.82. What is the ratio of the Domestic credit (% of GDP) of Croatia in 2008 to that in 2009?
Offer a very short reply. 0.96. What is the ratio of the Domestic credit (% of GDP) of Iceland in 2008 to that in 2009?
Offer a very short reply. 1.13. What is the ratio of the Domestic credit (% of GDP) in Mauritius in 2008 to that in 2009?
Provide a succinct answer. 1.02. What is the ratio of the Domestic credit (% of GDP) of Panama in 2008 to that in 2009?
Your response must be concise. 1.02. What is the ratio of the Domestic credit (% of GDP) of Croatia in 2008 to that in 2010?
Provide a short and direct response. 0.93. What is the ratio of the Domestic credit (% of GDP) of Iceland in 2008 to that in 2010?
Provide a short and direct response. 1.2. What is the ratio of the Domestic credit (% of GDP) of Mauritius in 2008 to that in 2010?
Ensure brevity in your answer.  0.97. What is the ratio of the Domestic credit (% of GDP) in Croatia in 2008 to that in 2011?
Your answer should be very brief. 0.91. What is the ratio of the Domestic credit (% of GDP) in Iceland in 2008 to that in 2011?
Offer a terse response. 1.4. What is the ratio of the Domestic credit (% of GDP) of Mauritius in 2008 to that in 2011?
Provide a short and direct response. 0.93. What is the ratio of the Domestic credit (% of GDP) in Panama in 2008 to that in 2011?
Provide a short and direct response. 0.99. What is the ratio of the Domestic credit (% of GDP) of Croatia in 2009 to that in 2010?
Ensure brevity in your answer.  0.97. What is the ratio of the Domestic credit (% of GDP) of Iceland in 2009 to that in 2010?
Give a very brief answer. 1.07. What is the ratio of the Domestic credit (% of GDP) in Mauritius in 2009 to that in 2010?
Your answer should be very brief. 0.94. What is the ratio of the Domestic credit (% of GDP) of Panama in 2009 to that in 2010?
Ensure brevity in your answer.  0.97. What is the ratio of the Domestic credit (% of GDP) in Croatia in 2009 to that in 2011?
Your answer should be very brief. 0.95. What is the ratio of the Domestic credit (% of GDP) of Iceland in 2009 to that in 2011?
Give a very brief answer. 1.25. What is the ratio of the Domestic credit (% of GDP) in Mauritius in 2009 to that in 2011?
Offer a terse response. 0.91. What is the ratio of the Domestic credit (% of GDP) of Panama in 2009 to that in 2011?
Offer a terse response. 0.97. What is the ratio of the Domestic credit (% of GDP) in Croatia in 2010 to that in 2011?
Provide a succinct answer. 0.97. What is the ratio of the Domestic credit (% of GDP) of Iceland in 2010 to that in 2011?
Your answer should be very brief. 1.17. What is the ratio of the Domestic credit (% of GDP) in Mauritius in 2010 to that in 2011?
Give a very brief answer. 0.96. What is the difference between the highest and the second highest Domestic credit (% of GDP) of Croatia?
Offer a very short reply. 1.84. What is the difference between the highest and the second highest Domestic credit (% of GDP) of Iceland?
Give a very brief answer. 61.39. What is the difference between the highest and the second highest Domestic credit (% of GDP) in Mauritius?
Ensure brevity in your answer.  3.59. What is the difference between the highest and the second highest Domestic credit (% of GDP) of Panama?
Your answer should be very brief. 1.8. What is the difference between the highest and the lowest Domestic credit (% of GDP) of Croatia?
Offer a terse response. 18.4. What is the difference between the highest and the lowest Domestic credit (% of GDP) in Iceland?
Offer a very short reply. 170.59. What is the difference between the highest and the lowest Domestic credit (% of GDP) of Mauritius?
Provide a succinct answer. 19.74. What is the difference between the highest and the lowest Domestic credit (% of GDP) in Panama?
Ensure brevity in your answer.  6.09. 